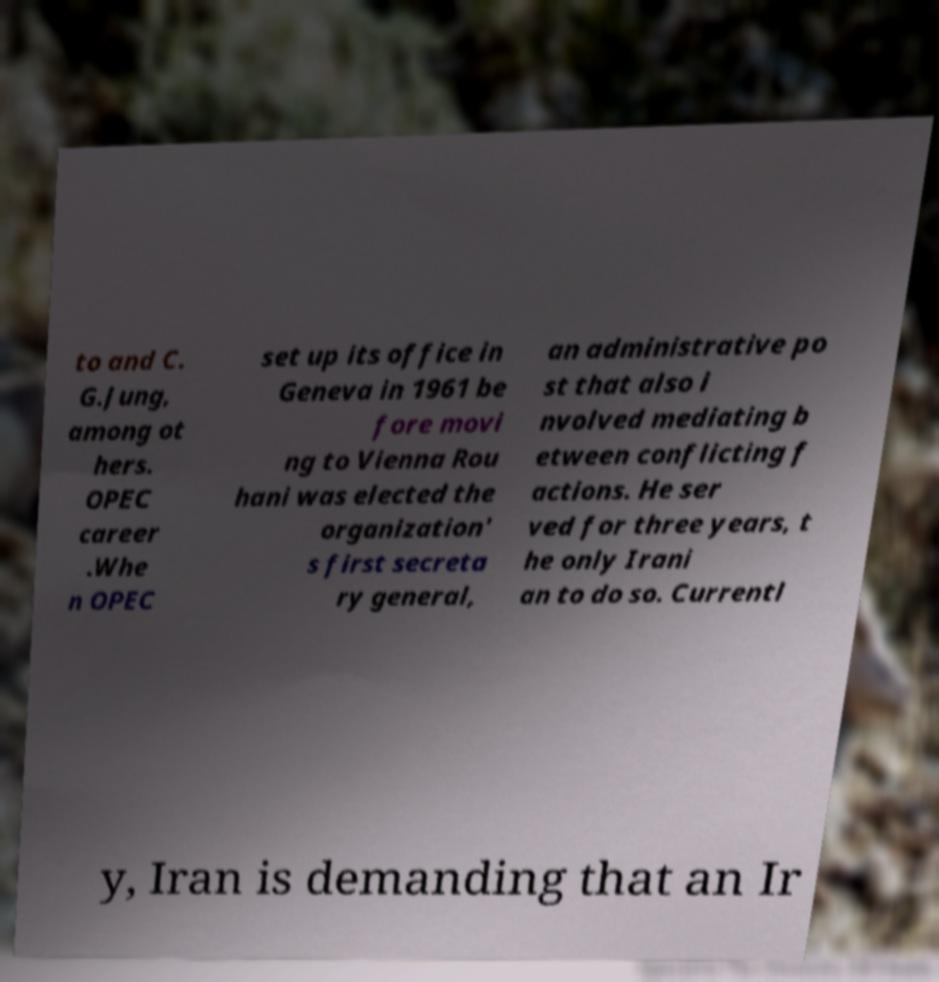What messages or text are displayed in this image? I need them in a readable, typed format. to and C. G.Jung, among ot hers. OPEC career .Whe n OPEC set up its office in Geneva in 1961 be fore movi ng to Vienna Rou hani was elected the organization' s first secreta ry general, an administrative po st that also i nvolved mediating b etween conflicting f actions. He ser ved for three years, t he only Irani an to do so. Currentl y, Iran is demanding that an Ir 